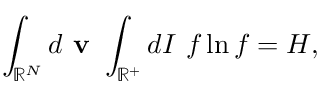<formula> <loc_0><loc_0><loc_500><loc_500>\int _ { \mathbb { R } ^ { N } } d v \int _ { \mathbb { R } ^ { + } } d I \ f \ln f = H ,</formula> 